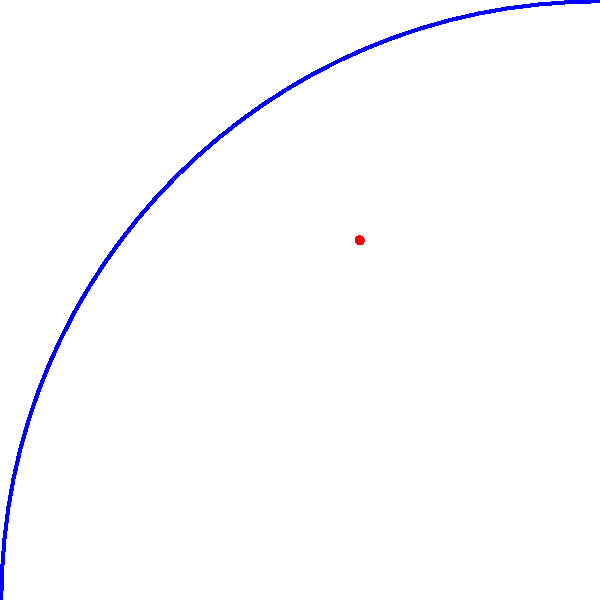An F1 car is exiting a turn on a track with a 15° upward gradient. The car's acceleration vector makes a 30° angle with the horizontal. If the magnitude of the acceleration is 5 m/s², what is the component of the acceleration parallel to the track surface? To solve this problem, we need to follow these steps:

1. Identify the relevant angles:
   - Track gradient: 15°
   - Acceleration vector angle with horizontal: 30°
   - Angle between acceleration vector and track surface: 30° - 15° = 15°

2. Use trigonometry to find the component of acceleration parallel to the track:
   - The parallel component is the adjacent side of a right triangle formed by the acceleration vector and the track surface.
   - We can use the cosine function to find this component.

3. Apply the cosine formula:
   $a_{parallel} = a \cos(\theta)$
   Where:
   $a$ is the magnitude of acceleration (5 m/s²)
   $\theta$ is the angle between the acceleration vector and the track surface (15°)

4. Calculate:
   $a_{parallel} = 5 \cos(15°)$
   $a_{parallel} = 5 \cdot 0.9659$
   $a_{parallel} = 4.83$ m/s²

Therefore, the component of acceleration parallel to the track surface is approximately 4.83 m/s².
Answer: 4.83 m/s² 